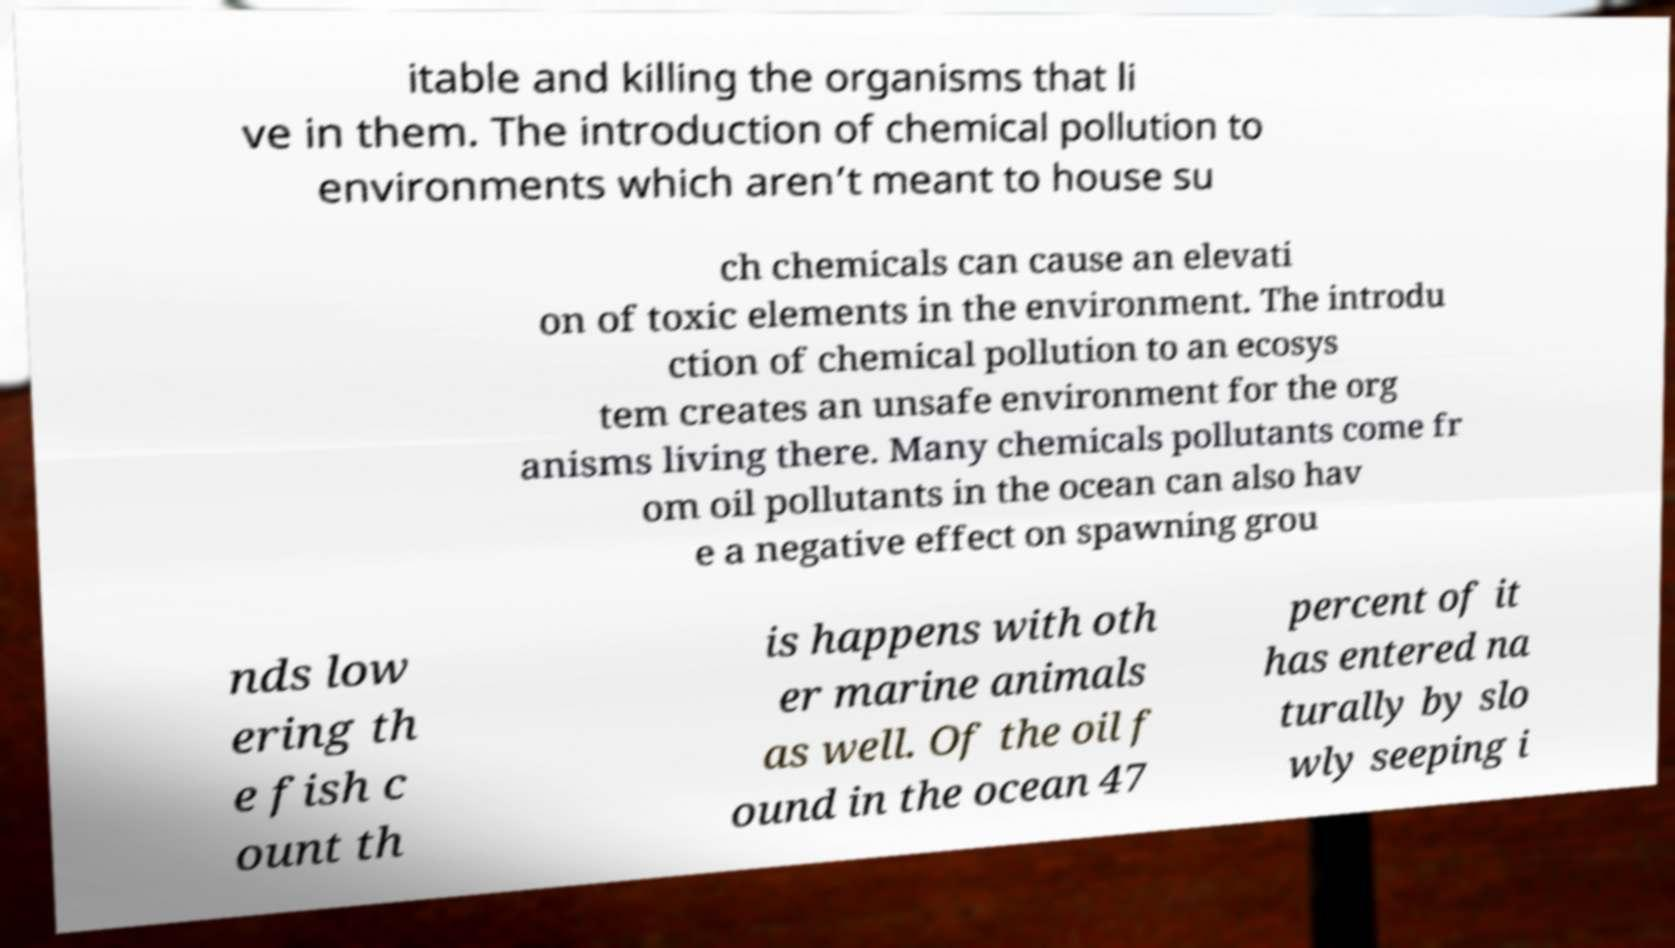There's text embedded in this image that I need extracted. Can you transcribe it verbatim? itable and killing the organisms that li ve in them. The introduction of chemical pollution to environments which aren’t meant to house su ch chemicals can cause an elevati on of toxic elements in the environment. The introdu ction of chemical pollution to an ecosys tem creates an unsafe environment for the org anisms living there. Many chemicals pollutants come fr om oil pollutants in the ocean can also hav e a negative effect on spawning grou nds low ering th e fish c ount th is happens with oth er marine animals as well. Of the oil f ound in the ocean 47 percent of it has entered na turally by slo wly seeping i 